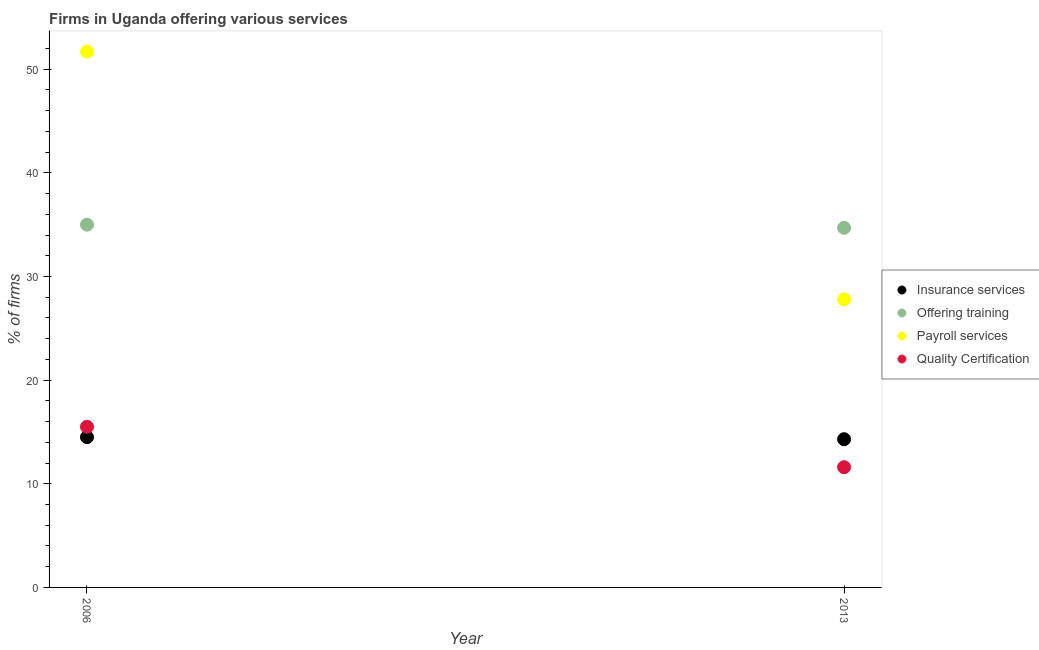Is the number of dotlines equal to the number of legend labels?
Your answer should be compact. Yes. What is the percentage of firms offering payroll services in 2013?
Keep it short and to the point. 27.8. Across all years, what is the minimum percentage of firms offering training?
Keep it short and to the point. 34.7. In which year was the percentage of firms offering quality certification minimum?
Your answer should be compact. 2013. What is the total percentage of firms offering training in the graph?
Give a very brief answer. 69.7. What is the difference between the percentage of firms offering training in 2006 and that in 2013?
Make the answer very short. 0.3. What is the difference between the percentage of firms offering training in 2006 and the percentage of firms offering payroll services in 2013?
Provide a succinct answer. 7.2. What is the average percentage of firms offering payroll services per year?
Make the answer very short. 39.75. In the year 2013, what is the difference between the percentage of firms offering training and percentage of firms offering insurance services?
Your answer should be compact. 20.4. What is the ratio of the percentage of firms offering quality certification in 2006 to that in 2013?
Your answer should be compact. 1.34. In how many years, is the percentage of firms offering quality certification greater than the average percentage of firms offering quality certification taken over all years?
Your answer should be very brief. 1. Is the percentage of firms offering training strictly greater than the percentage of firms offering payroll services over the years?
Make the answer very short. No. Is the percentage of firms offering quality certification strictly less than the percentage of firms offering insurance services over the years?
Ensure brevity in your answer.  No. What is the difference between two consecutive major ticks on the Y-axis?
Ensure brevity in your answer.  10. Are the values on the major ticks of Y-axis written in scientific E-notation?
Provide a short and direct response. No. Does the graph contain any zero values?
Make the answer very short. No. Does the graph contain grids?
Provide a succinct answer. No. Where does the legend appear in the graph?
Keep it short and to the point. Center right. What is the title of the graph?
Provide a succinct answer. Firms in Uganda offering various services . Does "International Development Association" appear as one of the legend labels in the graph?
Give a very brief answer. No. What is the label or title of the Y-axis?
Your response must be concise. % of firms. What is the % of firms of Payroll services in 2006?
Keep it short and to the point. 51.7. What is the % of firms of Quality Certification in 2006?
Provide a succinct answer. 15.5. What is the % of firms of Offering training in 2013?
Your answer should be compact. 34.7. What is the % of firms of Payroll services in 2013?
Give a very brief answer. 27.8. Across all years, what is the maximum % of firms in Insurance services?
Provide a short and direct response. 14.5. Across all years, what is the maximum % of firms in Offering training?
Provide a short and direct response. 35. Across all years, what is the maximum % of firms of Payroll services?
Offer a terse response. 51.7. Across all years, what is the maximum % of firms of Quality Certification?
Offer a very short reply. 15.5. Across all years, what is the minimum % of firms in Insurance services?
Keep it short and to the point. 14.3. Across all years, what is the minimum % of firms of Offering training?
Give a very brief answer. 34.7. Across all years, what is the minimum % of firms of Payroll services?
Offer a terse response. 27.8. What is the total % of firms of Insurance services in the graph?
Your answer should be very brief. 28.8. What is the total % of firms in Offering training in the graph?
Give a very brief answer. 69.7. What is the total % of firms of Payroll services in the graph?
Offer a terse response. 79.5. What is the total % of firms in Quality Certification in the graph?
Your answer should be compact. 27.1. What is the difference between the % of firms of Offering training in 2006 and that in 2013?
Offer a terse response. 0.3. What is the difference between the % of firms in Payroll services in 2006 and that in 2013?
Your response must be concise. 23.9. What is the difference between the % of firms in Quality Certification in 2006 and that in 2013?
Offer a very short reply. 3.9. What is the difference between the % of firms of Insurance services in 2006 and the % of firms of Offering training in 2013?
Give a very brief answer. -20.2. What is the difference between the % of firms in Offering training in 2006 and the % of firms in Payroll services in 2013?
Give a very brief answer. 7.2. What is the difference between the % of firms of Offering training in 2006 and the % of firms of Quality Certification in 2013?
Keep it short and to the point. 23.4. What is the difference between the % of firms in Payroll services in 2006 and the % of firms in Quality Certification in 2013?
Ensure brevity in your answer.  40.1. What is the average % of firms in Offering training per year?
Provide a succinct answer. 34.85. What is the average % of firms in Payroll services per year?
Your response must be concise. 39.75. What is the average % of firms in Quality Certification per year?
Your response must be concise. 13.55. In the year 2006, what is the difference between the % of firms of Insurance services and % of firms of Offering training?
Provide a short and direct response. -20.5. In the year 2006, what is the difference between the % of firms in Insurance services and % of firms in Payroll services?
Ensure brevity in your answer.  -37.2. In the year 2006, what is the difference between the % of firms in Offering training and % of firms in Payroll services?
Offer a very short reply. -16.7. In the year 2006, what is the difference between the % of firms of Payroll services and % of firms of Quality Certification?
Provide a short and direct response. 36.2. In the year 2013, what is the difference between the % of firms in Insurance services and % of firms in Offering training?
Ensure brevity in your answer.  -20.4. In the year 2013, what is the difference between the % of firms in Offering training and % of firms in Quality Certification?
Your response must be concise. 23.1. What is the ratio of the % of firms of Offering training in 2006 to that in 2013?
Your answer should be very brief. 1.01. What is the ratio of the % of firms of Payroll services in 2006 to that in 2013?
Your response must be concise. 1.86. What is the ratio of the % of firms of Quality Certification in 2006 to that in 2013?
Ensure brevity in your answer.  1.34. What is the difference between the highest and the second highest % of firms in Payroll services?
Keep it short and to the point. 23.9. What is the difference between the highest and the lowest % of firms of Insurance services?
Give a very brief answer. 0.2. What is the difference between the highest and the lowest % of firms of Offering training?
Provide a succinct answer. 0.3. What is the difference between the highest and the lowest % of firms in Payroll services?
Give a very brief answer. 23.9. 